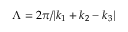Convert formula to latex. <formula><loc_0><loc_0><loc_500><loc_500>\Lambda = 2 \pi / | k _ { 1 } + k _ { 2 } - k _ { 3 } |</formula> 